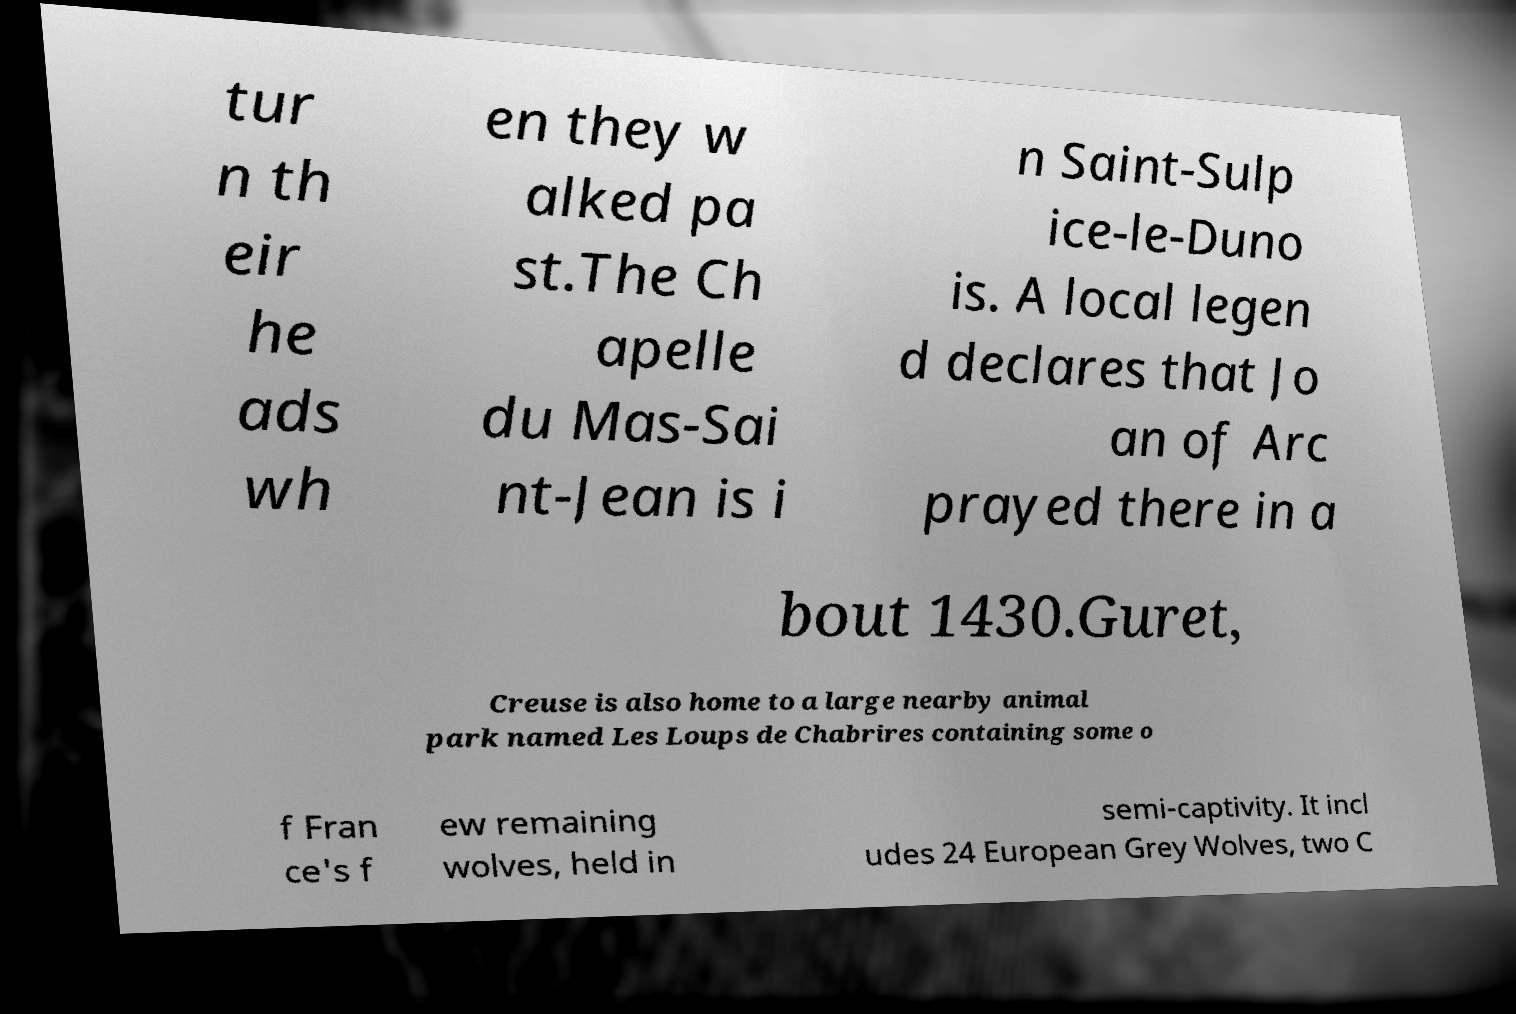I need the written content from this picture converted into text. Can you do that? tur n th eir he ads wh en they w alked pa st.The Ch apelle du Mas-Sai nt-Jean is i n Saint-Sulp ice-le-Duno is. A local legen d declares that Jo an of Arc prayed there in a bout 1430.Guret, Creuse is also home to a large nearby animal park named Les Loups de Chabrires containing some o f Fran ce's f ew remaining wolves, held in semi-captivity. It incl udes 24 European Grey Wolves, two C 